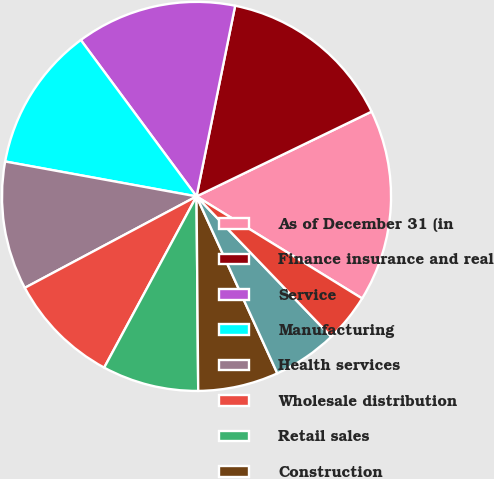Convert chart to OTSL. <chart><loc_0><loc_0><loc_500><loc_500><pie_chart><fcel>As of December 31 (in<fcel>Finance insurance and real<fcel>Service<fcel>Manufacturing<fcel>Health services<fcel>Wholesale distribution<fcel>Retail sales<fcel>Construction<fcel>Transportation/utility<fcel>Arts/entertainment/recreation<nl><fcel>15.97%<fcel>14.64%<fcel>13.32%<fcel>11.99%<fcel>10.66%<fcel>9.34%<fcel>8.01%<fcel>6.68%<fcel>5.36%<fcel>4.03%<nl></chart> 